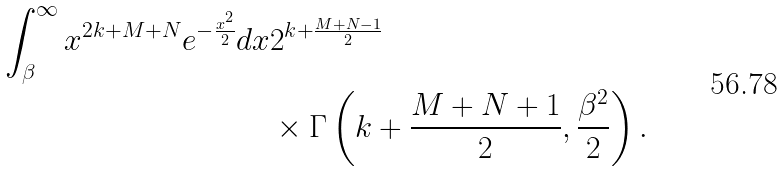Convert formula to latex. <formula><loc_0><loc_0><loc_500><loc_500>\int _ { \beta } ^ { \infty } x ^ { 2 k + M + N } e ^ { - \frac { x ^ { 2 } } { 2 } } d x & 2 ^ { k + \frac { M + N - 1 } { 2 } } \\ & \times \Gamma \left ( k + \frac { M + N + 1 } { 2 } , \frac { \beta ^ { 2 } } { 2 } \right ) .</formula> 